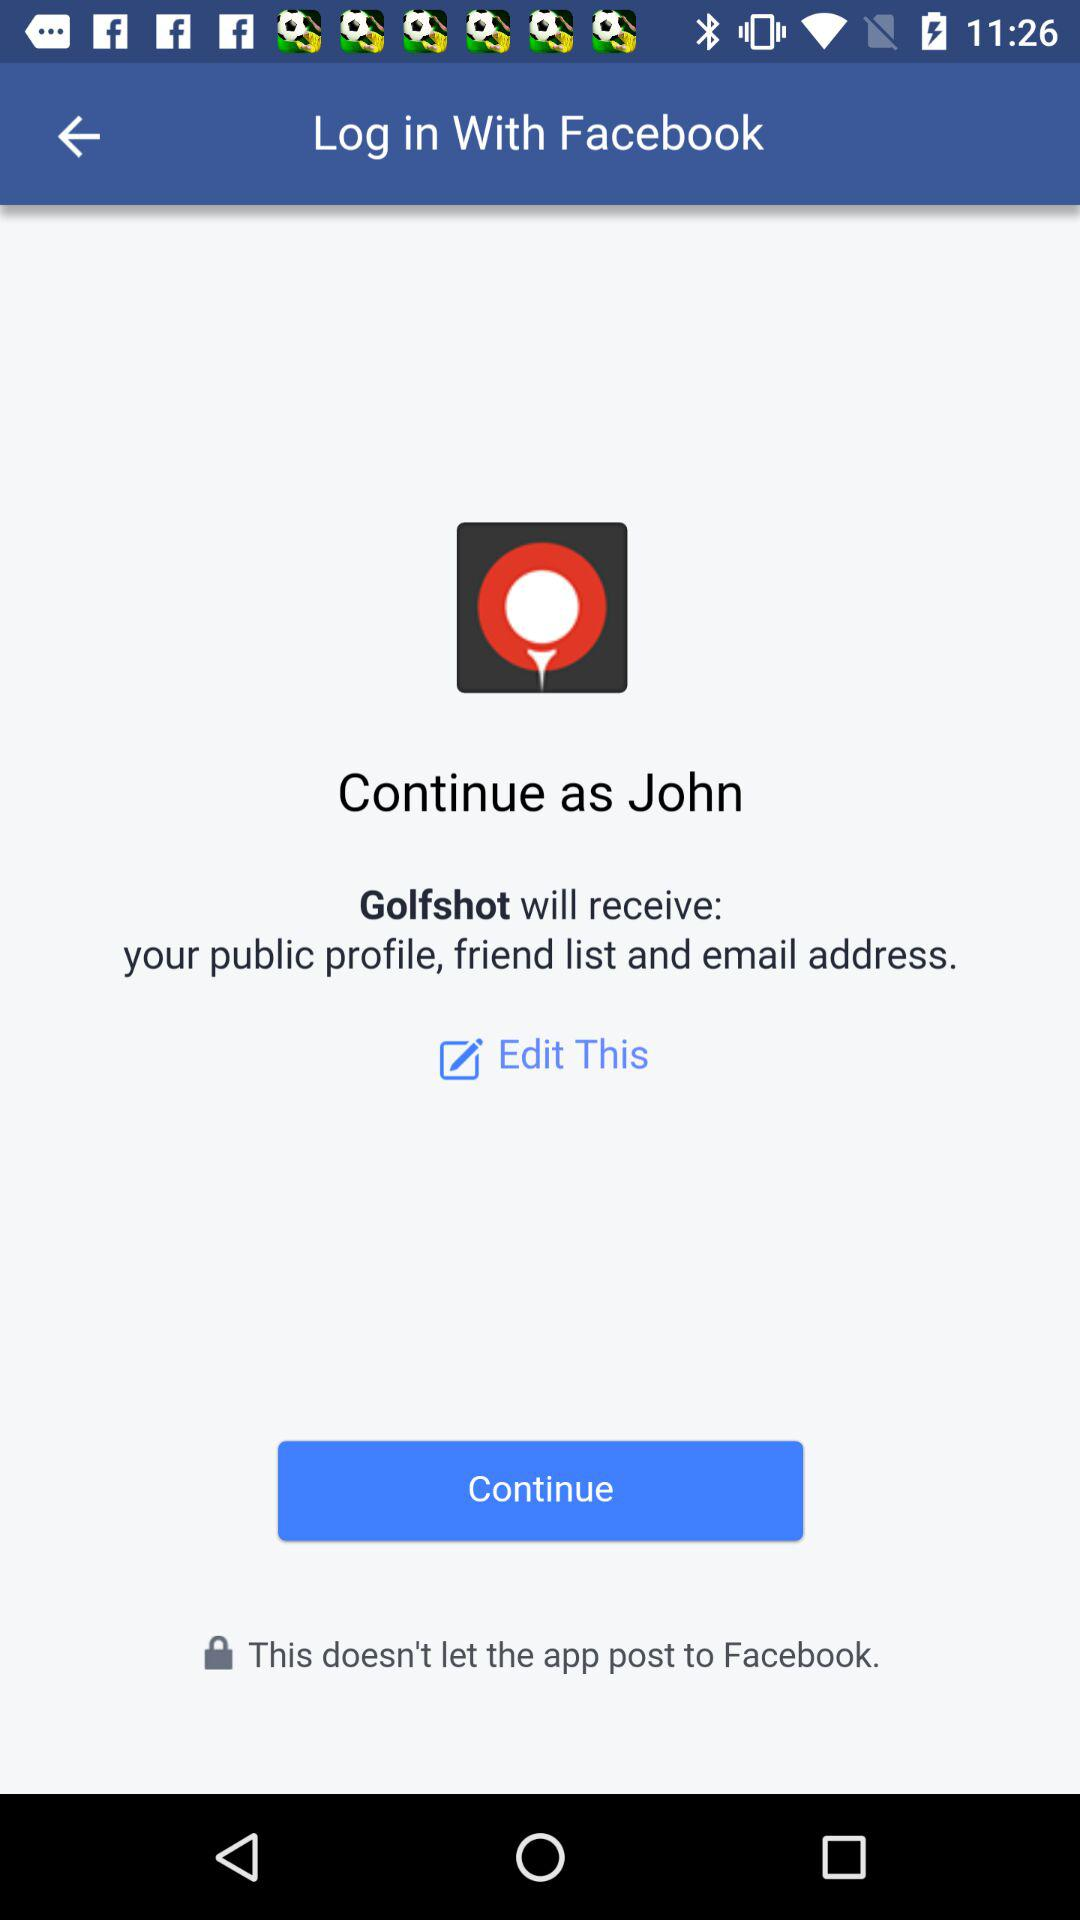What application will receive the public profile and email address? The application that will receive the public profile and email address is "Golfshot". 